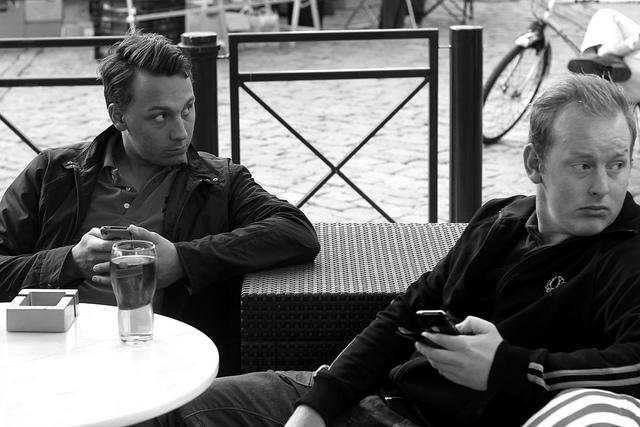How many men are there?
Answer briefly. 2. What is in the glass on the table?
Give a very brief answer. Water. Do the men look like they've just been interrupted?
Be succinct. Yes. 